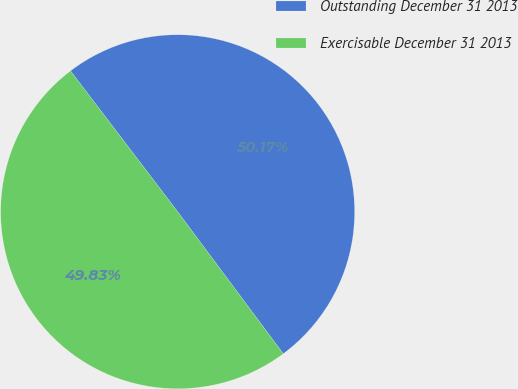Convert chart to OTSL. <chart><loc_0><loc_0><loc_500><loc_500><pie_chart><fcel>Outstanding December 31 2013<fcel>Exercisable December 31 2013<nl><fcel>50.17%<fcel>49.83%<nl></chart> 